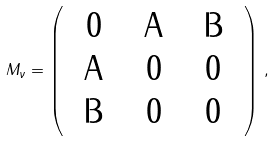Convert formula to latex. <formula><loc_0><loc_0><loc_500><loc_500>M _ { \nu } = \left ( \begin{array} { c c c } 0 & $ A $ & $ B $ \\ $ A $ & 0 & 0 \\ $ B $ & 0 & 0 \end{array} \right ) \, ,</formula> 